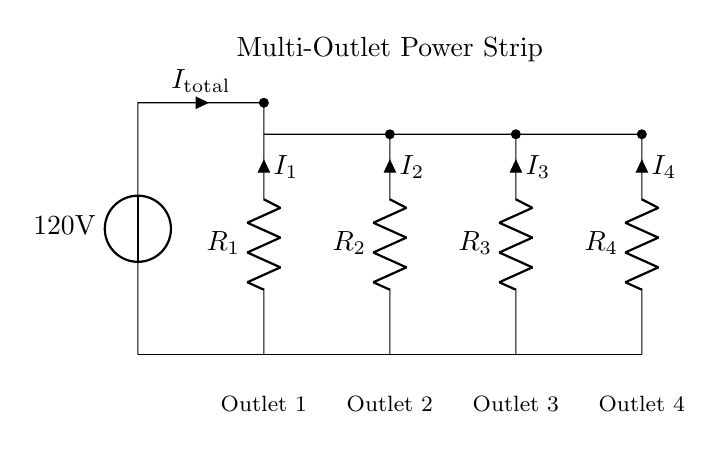What is the total voltage supplied to the circuit? The total voltage supplied is 120 volts, as indicated by the voltage source label in the diagram.
Answer: 120 volts What type of circuit is shown in the diagram? The circuit is a parallel circuit, evidenced by the multiple branches where each resistor is connected independently to the voltage source.
Answer: Parallel How many outlets are shown in the power strip? There are four outlets depicted in the circuit diagram, corresponding to each branch leading to the resistors.
Answer: Four What are the current labels for outlet 3? The current label for outlet 3 is defined as I3, which represents the current flowing through the corresponding resistor for that outlet.
Answer: I3 What is the relationship between total current and individual currents in this circuit? In a parallel circuit, the total current is equal to the sum of the currents in each branch, which means that I total equals I1 plus I2 plus I3 plus I4.
Answer: I total = I1 + I2 + I3 + I4 What happens to the voltage across each outlet? The voltage across each outlet is the same, which is 120 volts, since they are connected in parallel with the same source voltage.
Answer: 120 volts Which component controls the current in each outlet? Each outlet has a resistor, which controls the amount of current that flows through that particular branch in the circuit.
Answer: Resistor 